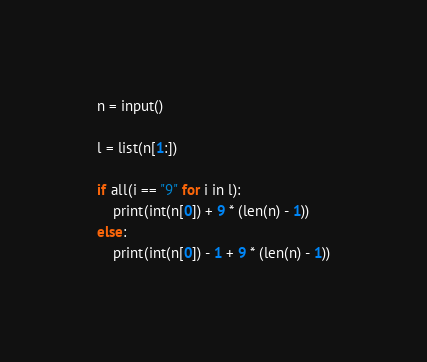<code> <loc_0><loc_0><loc_500><loc_500><_Python_>n = input()

l = list(n[1:])

if all(i == "9" for i in l):
    print(int(n[0]) + 9 * (len(n) - 1))
else:
    print(int(n[0]) - 1 + 9 * (len(n) - 1))</code> 